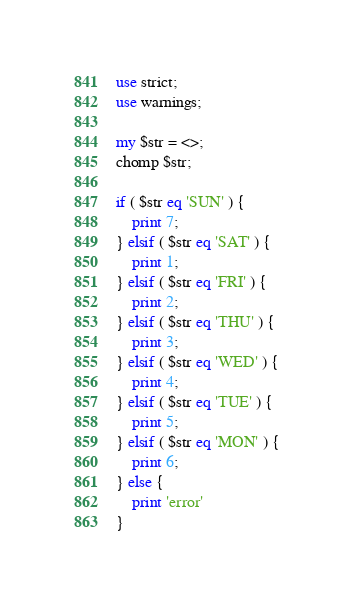Convert code to text. <code><loc_0><loc_0><loc_500><loc_500><_Perl_>use strict;
use warnings;

my $str = <>;
chomp $str;

if ( $str eq 'SUN' ) {
    print 7;
} elsif ( $str eq 'SAT' ) {
    print 1;
} elsif ( $str eq 'FRI' ) {
    print 2;
} elsif ( $str eq 'THU' ) {
    print 3;
} elsif ( $str eq 'WED' ) {
    print 4;
} elsif ( $str eq 'TUE' ) {
    print 5;
} elsif ( $str eq 'MON' ) {
    print 6;
} else {
    print 'error'
}

</code> 